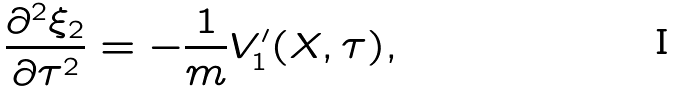Convert formula to latex. <formula><loc_0><loc_0><loc_500><loc_500>\frac { \partial ^ { 2 } \xi _ { 2 } } { \partial \tau ^ { 2 } } = - \frac { 1 } { m } V _ { 1 } ^ { \prime } ( X , \tau ) ,</formula> 